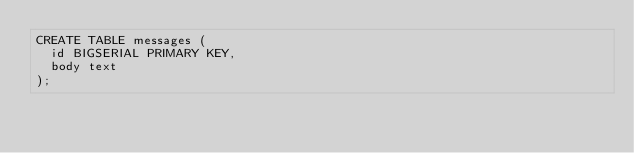<code> <loc_0><loc_0><loc_500><loc_500><_SQL_>CREATE TABLE messages (
  id BIGSERIAL PRIMARY KEY,
  body text
);
</code> 